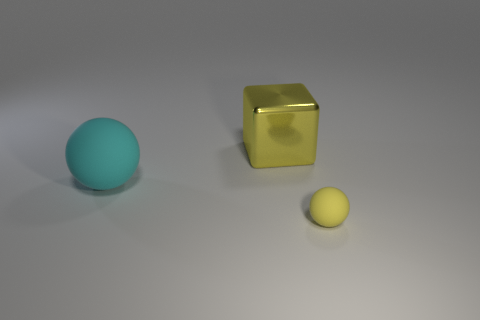Add 2 big cyan things. How many objects exist? 5 Subtract all balls. How many objects are left? 1 Subtract all green cubes. Subtract all red balls. How many cubes are left? 1 Subtract all yellow cylinders. How many yellow spheres are left? 1 Subtract all shiny cubes. Subtract all big metal objects. How many objects are left? 1 Add 1 yellow rubber balls. How many yellow rubber balls are left? 2 Add 1 blue things. How many blue things exist? 1 Subtract 0 green blocks. How many objects are left? 3 Subtract 1 blocks. How many blocks are left? 0 